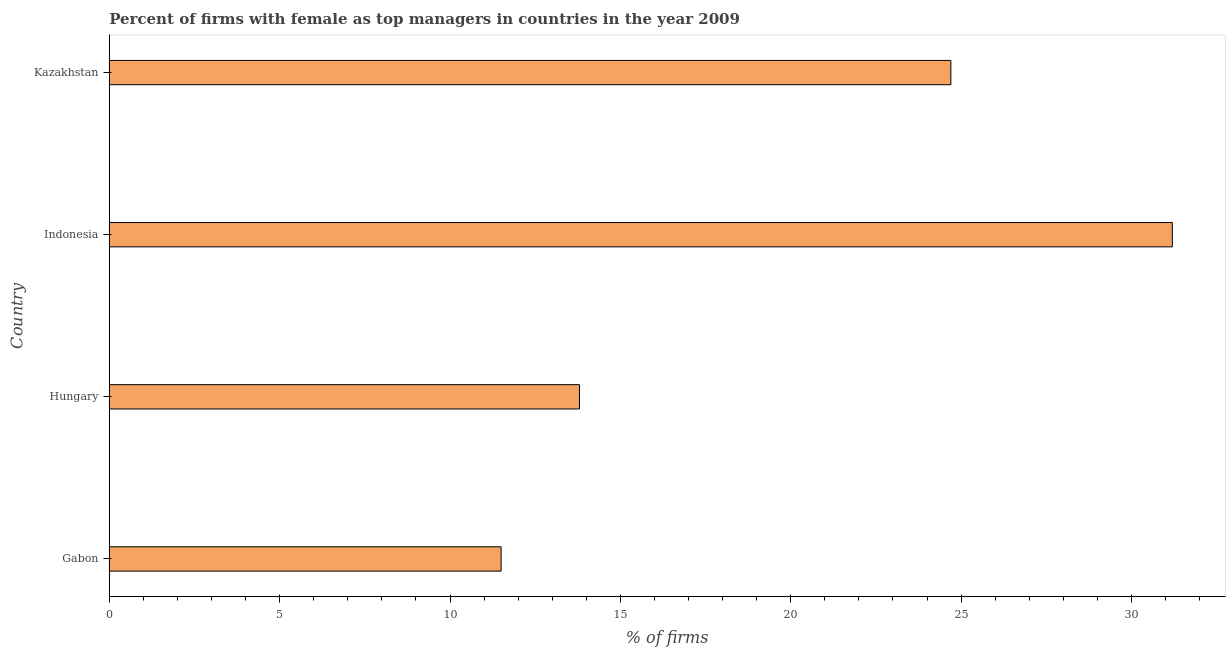Does the graph contain any zero values?
Keep it short and to the point. No. What is the title of the graph?
Give a very brief answer. Percent of firms with female as top managers in countries in the year 2009. What is the label or title of the X-axis?
Your answer should be very brief. % of firms. Across all countries, what is the maximum percentage of firms with female as top manager?
Your answer should be compact. 31.2. In which country was the percentage of firms with female as top manager maximum?
Keep it short and to the point. Indonesia. In which country was the percentage of firms with female as top manager minimum?
Keep it short and to the point. Gabon. What is the sum of the percentage of firms with female as top manager?
Your response must be concise. 81.2. What is the difference between the percentage of firms with female as top manager in Gabon and Hungary?
Ensure brevity in your answer.  -2.3. What is the average percentage of firms with female as top manager per country?
Your response must be concise. 20.3. What is the median percentage of firms with female as top manager?
Your answer should be very brief. 19.25. What is the ratio of the percentage of firms with female as top manager in Hungary to that in Indonesia?
Your answer should be very brief. 0.44. Is the sum of the percentage of firms with female as top manager in Hungary and Kazakhstan greater than the maximum percentage of firms with female as top manager across all countries?
Provide a succinct answer. Yes. In how many countries, is the percentage of firms with female as top manager greater than the average percentage of firms with female as top manager taken over all countries?
Offer a very short reply. 2. How many bars are there?
Your answer should be compact. 4. Are all the bars in the graph horizontal?
Provide a short and direct response. Yes. Are the values on the major ticks of X-axis written in scientific E-notation?
Provide a short and direct response. No. What is the % of firms in Gabon?
Keep it short and to the point. 11.5. What is the % of firms of Indonesia?
Make the answer very short. 31.2. What is the % of firms of Kazakhstan?
Give a very brief answer. 24.7. What is the difference between the % of firms in Gabon and Hungary?
Ensure brevity in your answer.  -2.3. What is the difference between the % of firms in Gabon and Indonesia?
Offer a terse response. -19.7. What is the difference between the % of firms in Gabon and Kazakhstan?
Keep it short and to the point. -13.2. What is the difference between the % of firms in Hungary and Indonesia?
Provide a succinct answer. -17.4. What is the difference between the % of firms in Indonesia and Kazakhstan?
Your answer should be very brief. 6.5. What is the ratio of the % of firms in Gabon to that in Hungary?
Your answer should be very brief. 0.83. What is the ratio of the % of firms in Gabon to that in Indonesia?
Provide a short and direct response. 0.37. What is the ratio of the % of firms in Gabon to that in Kazakhstan?
Offer a terse response. 0.47. What is the ratio of the % of firms in Hungary to that in Indonesia?
Keep it short and to the point. 0.44. What is the ratio of the % of firms in Hungary to that in Kazakhstan?
Offer a very short reply. 0.56. What is the ratio of the % of firms in Indonesia to that in Kazakhstan?
Give a very brief answer. 1.26. 